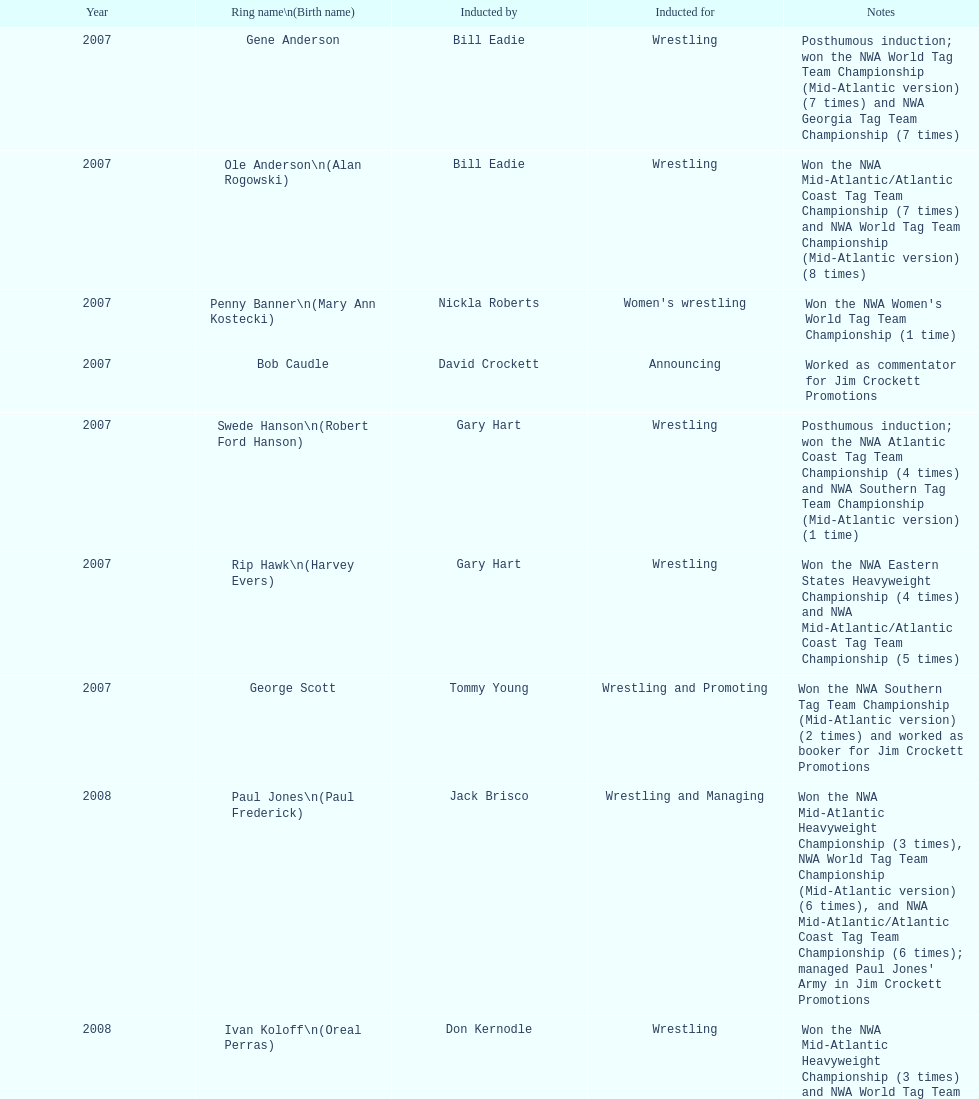Bob caudle was an announcer, who was the additional one? Lance Russell. 